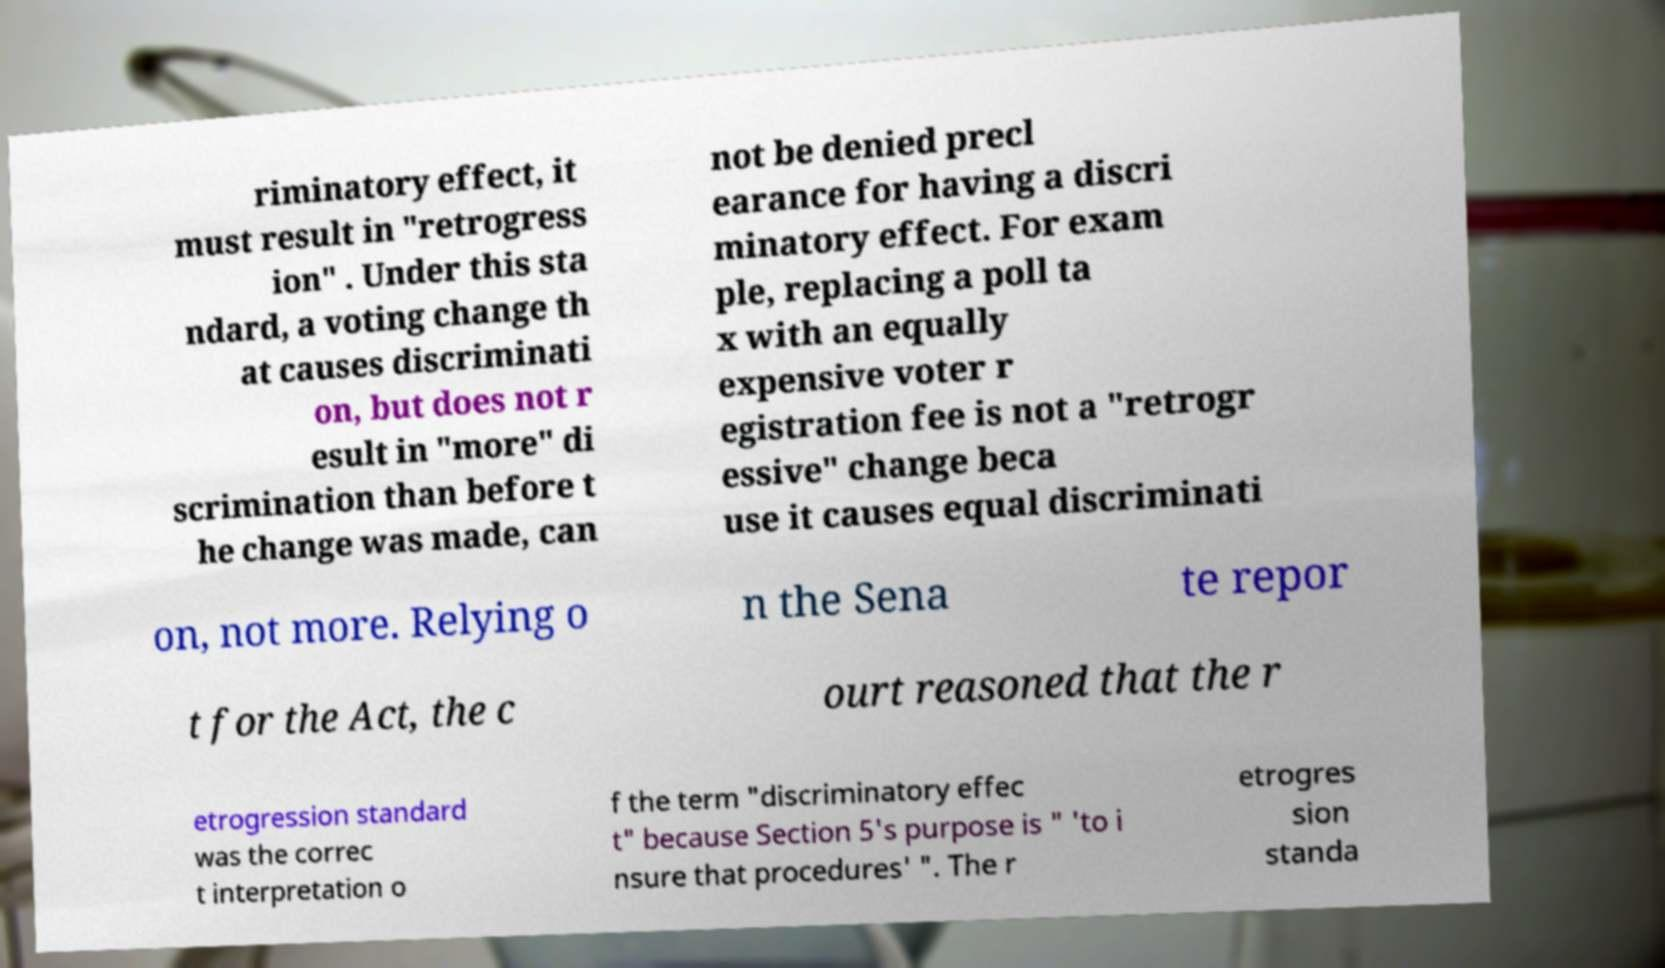There's text embedded in this image that I need extracted. Can you transcribe it verbatim? riminatory effect, it must result in "retrogress ion" . Under this sta ndard, a voting change th at causes discriminati on, but does not r esult in "more" di scrimination than before t he change was made, can not be denied precl earance for having a discri minatory effect. For exam ple, replacing a poll ta x with an equally expensive voter r egistration fee is not a "retrogr essive" change beca use it causes equal discriminati on, not more. Relying o n the Sena te repor t for the Act, the c ourt reasoned that the r etrogression standard was the correc t interpretation o f the term "discriminatory effec t" because Section 5's purpose is " 'to i nsure that procedures' ". The r etrogres sion standa 